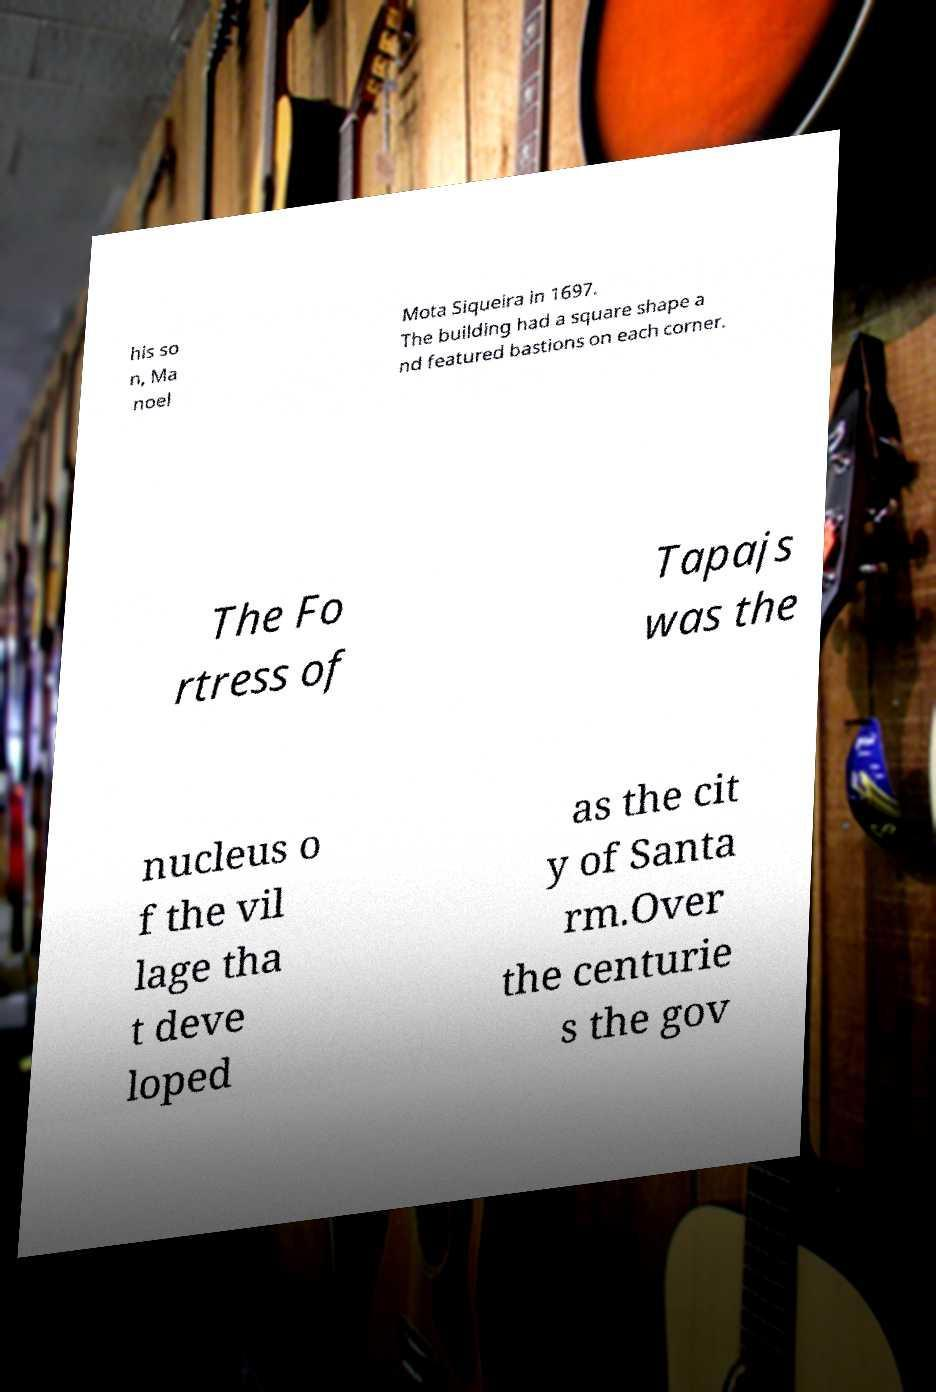Can you read and provide the text displayed in the image?This photo seems to have some interesting text. Can you extract and type it out for me? his so n, Ma noel Mota Siqueira in 1697. The building had a square shape a nd featured bastions on each corner. The Fo rtress of Tapajs was the nucleus o f the vil lage tha t deve loped as the cit y of Santa rm.Over the centurie s the gov 